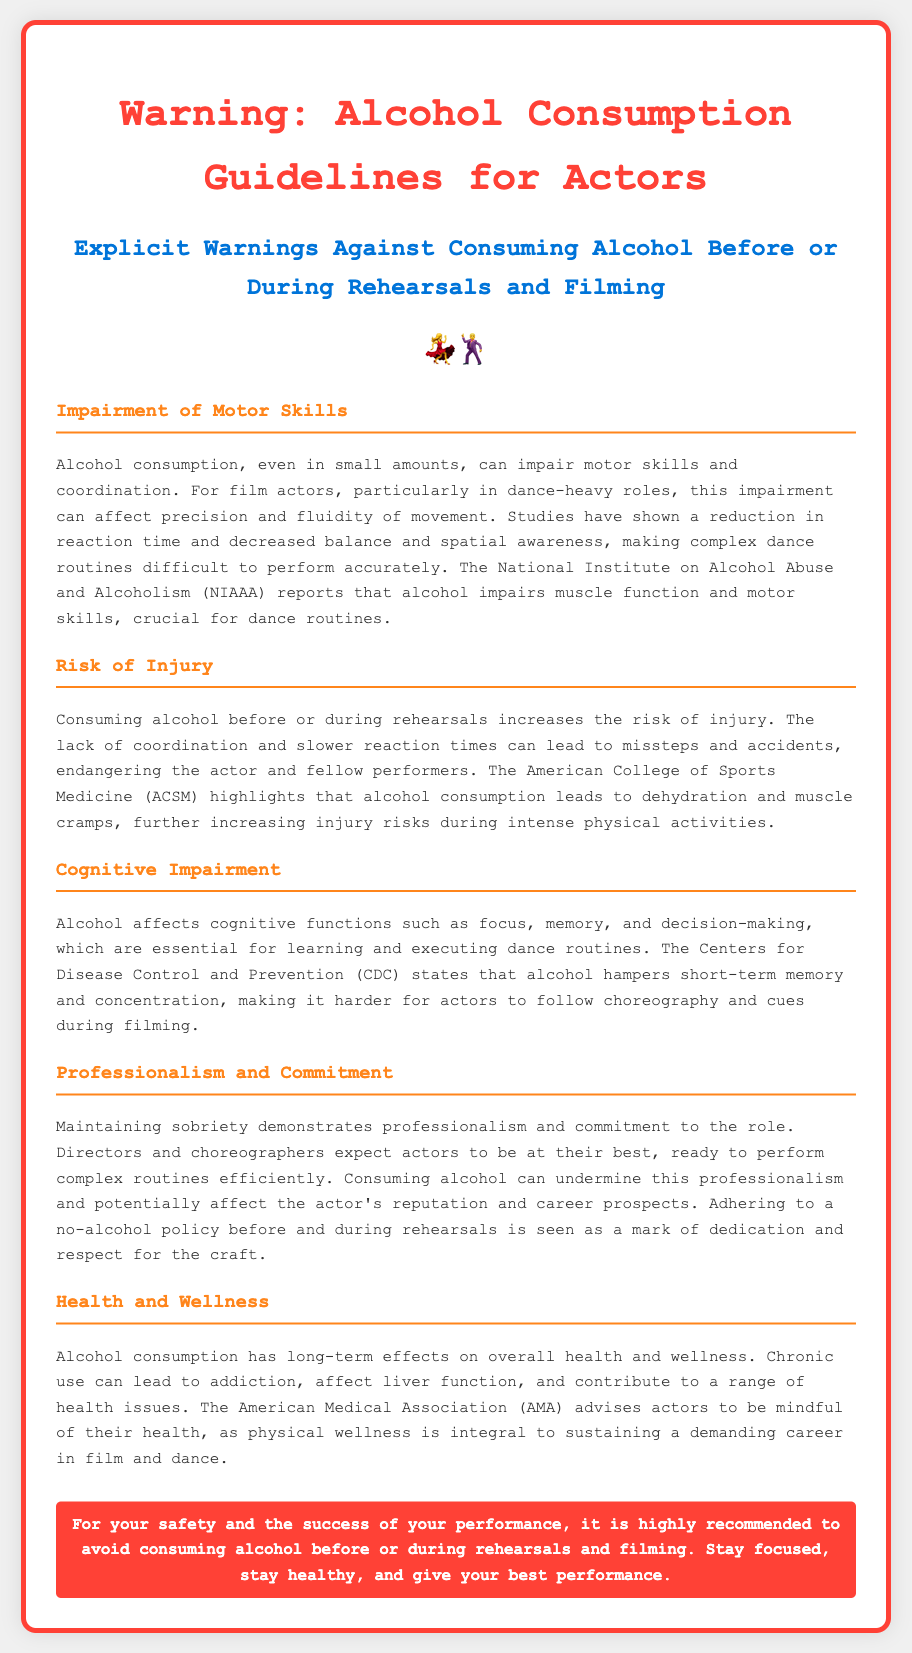What is the title of the document? The title of the document is in the header of the page, which clearly states its subject.
Answer: Warning: Alcohol Consumption Guidelines for Actors What are the explicit warnings about? The explicit warnings highlighted in the document pertain specifically to the actions that actors should avoid.
Answer: Consuming alcohol before or during rehearsals and filming What is impaired by alcohol consumption according to the document? The document specifically mentions certain skills that are compromised due to alcohol.
Answer: Motor skills and coordination Which organization reports that alcohol impairs muscle function? The document cites an authoritative organization regarding the impairments caused by alcohol.
Answer: National Institute on Alcohol Abuse and Alcoholism (NIAAA) What effect does alcohol have on cognitive functions? The document discusses how alcohol impacts a specific set of functions necessary for a performance.
Answer: Affects focus, memory, and decision-making According to the document, what increases the risk of injury? The document identifies a behavior that directly correlates with heightened injury risks during performances.
Answer: Consuming alcohol before or during rehearsals What is considered a mark of dedication for actors? The document mentions an action that reflects a serious commitment and respect for their craft.
Answer: Adhering to a no-alcohol policy Which organization warns about the health implications of chronic alcohol use? The text refers to a specific organization that provides advice regarding long-term health risks associated with alcohol.
Answer: American Medical Association (AMA) What is the document's primary recommendation for actors regarding alcohol? The document offers a straightforward guideline that all actors are encouraged to follow.
Answer: Avoid consuming alcohol before or during rehearsals and filming 